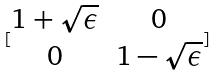Convert formula to latex. <formula><loc_0><loc_0><loc_500><loc_500>[ \begin{matrix} 1 + \sqrt { \epsilon } & 0 \\ 0 & 1 - \sqrt { \epsilon } \end{matrix} ]</formula> 